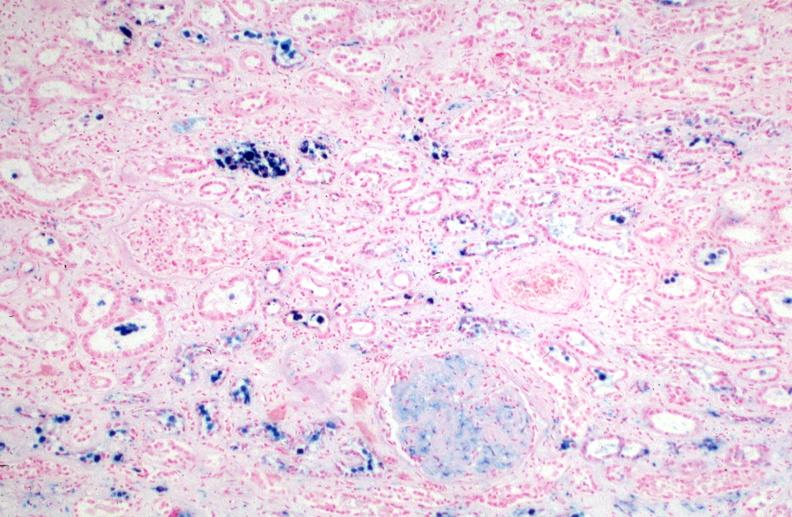what caused by numerous blood transfusions.prusian blue?
Answer the question using a single word or phrase. Hemosiderosis 